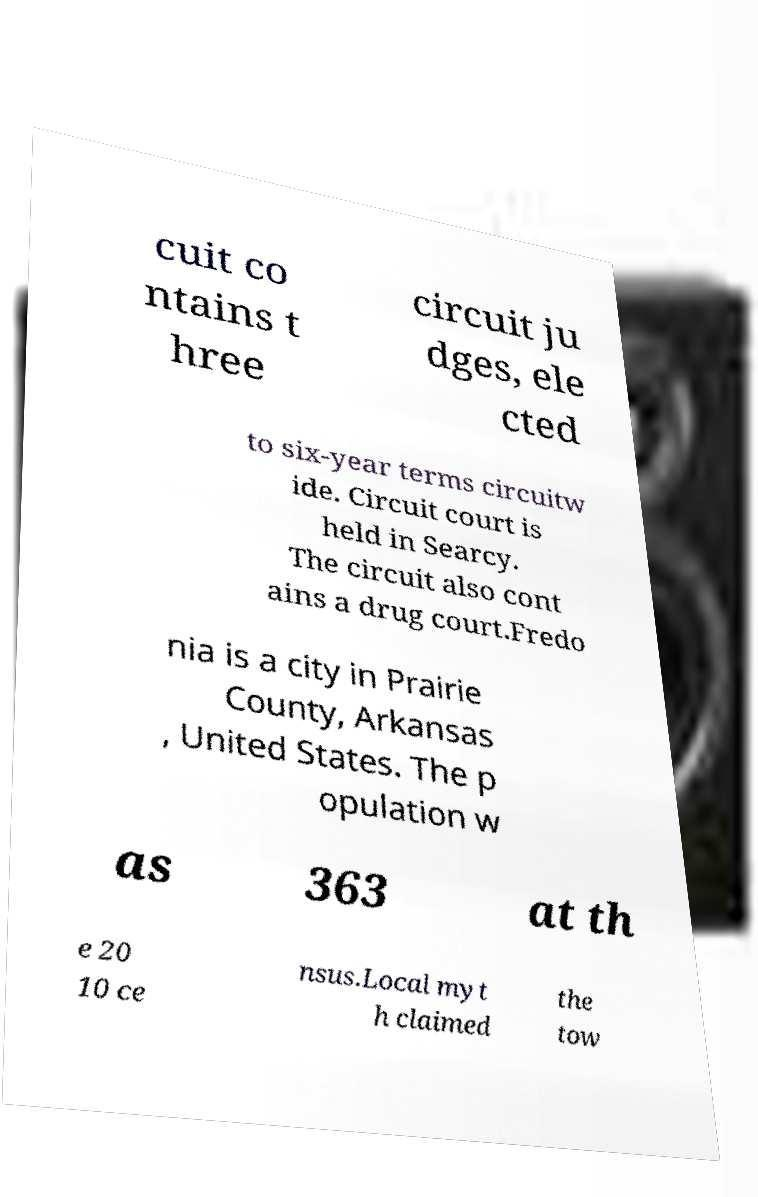What messages or text are displayed in this image? I need them in a readable, typed format. cuit co ntains t hree circuit ju dges, ele cted to six-year terms circuitw ide. Circuit court is held in Searcy. The circuit also cont ains a drug court.Fredo nia is a city in Prairie County, Arkansas , United States. The p opulation w as 363 at th e 20 10 ce nsus.Local myt h claimed the tow 